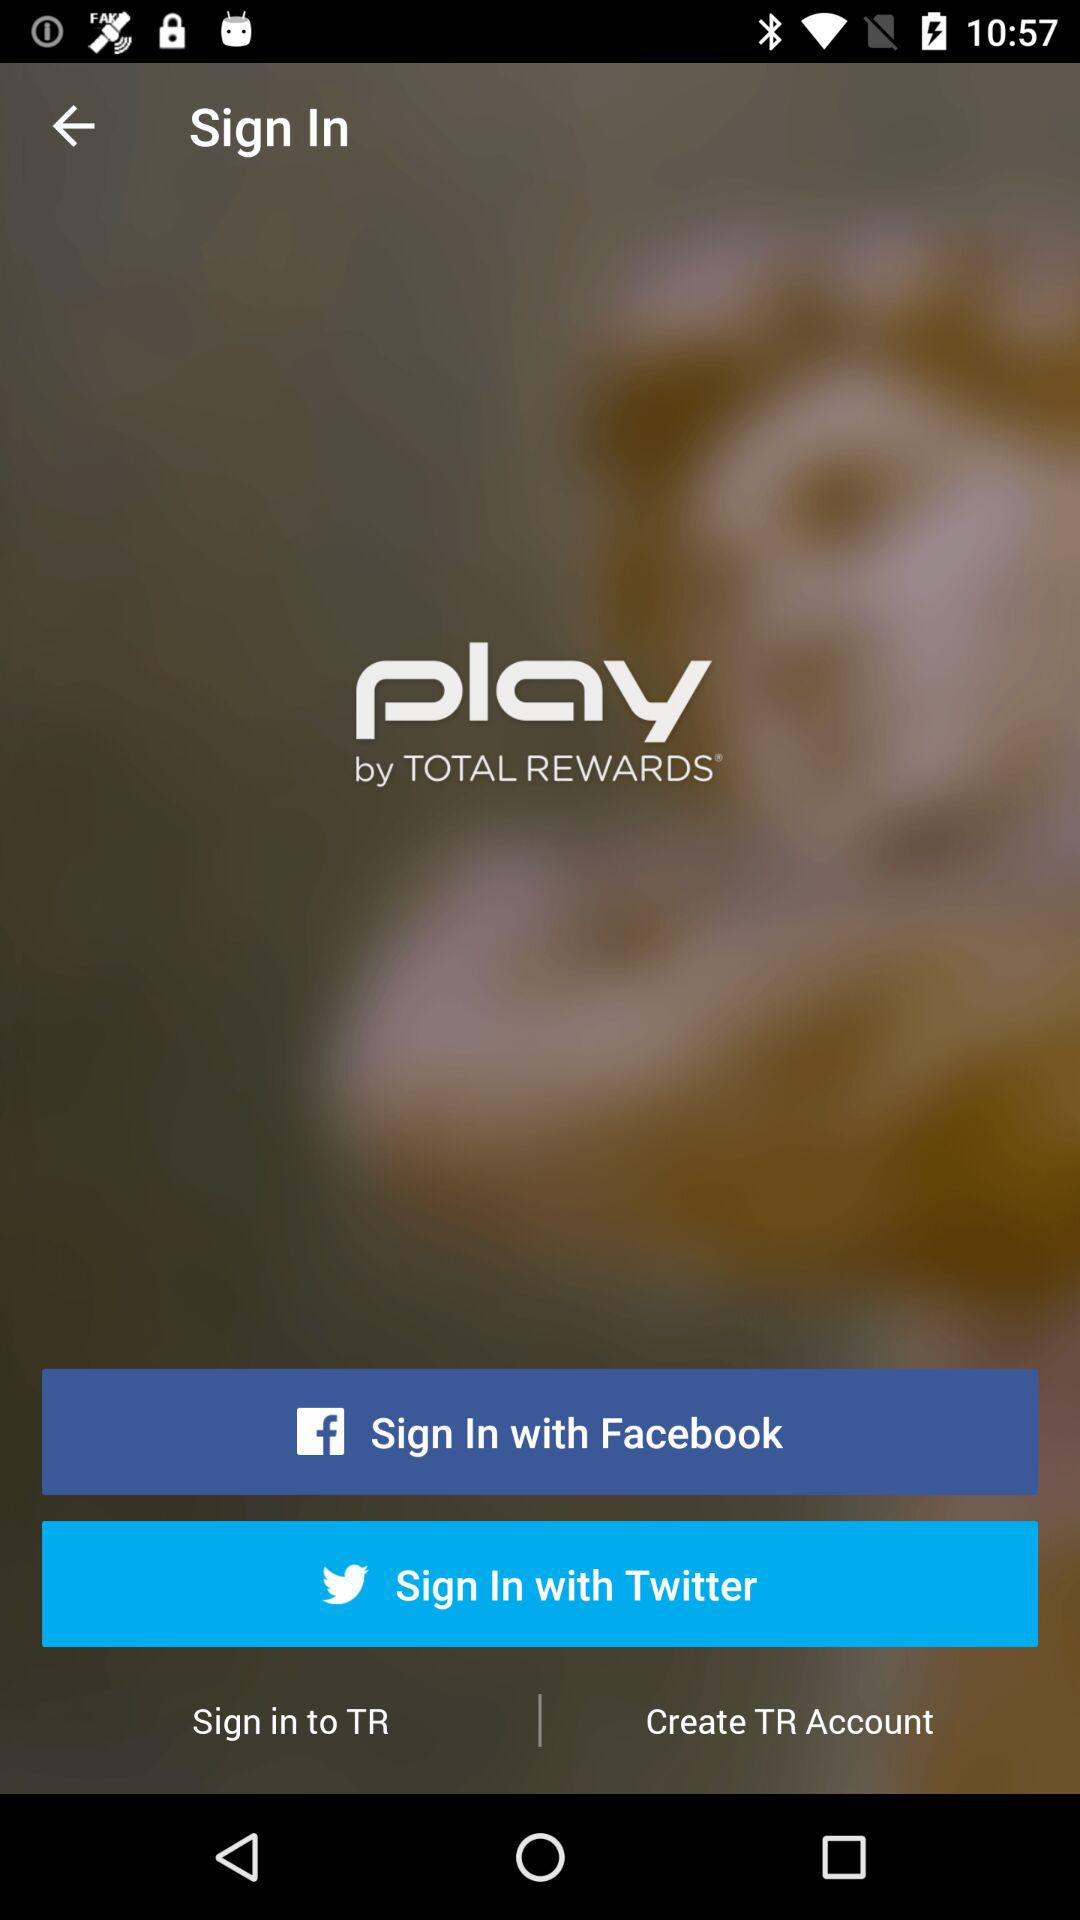What is the name of the application? The name of the application is "play". 